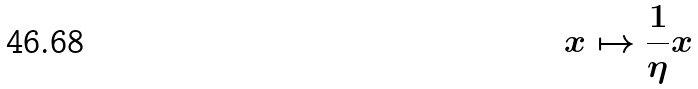<formula> <loc_0><loc_0><loc_500><loc_500>x \mapsto \frac { 1 } { \eta } x</formula> 